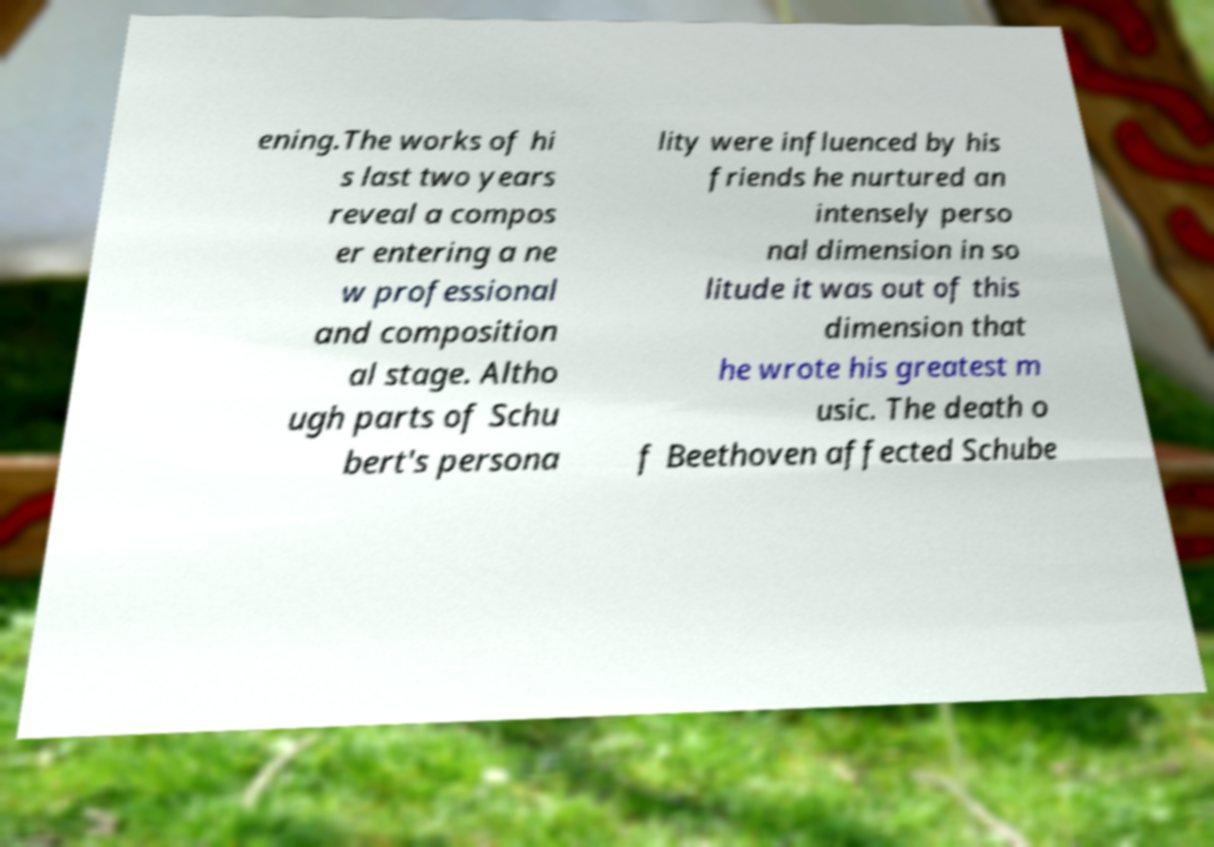Please identify and transcribe the text found in this image. ening.The works of hi s last two years reveal a compos er entering a ne w professional and composition al stage. Altho ugh parts of Schu bert's persona lity were influenced by his friends he nurtured an intensely perso nal dimension in so litude it was out of this dimension that he wrote his greatest m usic. The death o f Beethoven affected Schube 